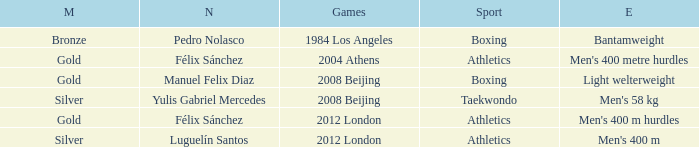Which Name had a Games of 2008 beijing, and a Medal of gold? Manuel Felix Diaz. 